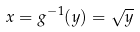Convert formula to latex. <formula><loc_0><loc_0><loc_500><loc_500>x = g ^ { - 1 } ( y ) = \sqrt { y }</formula> 